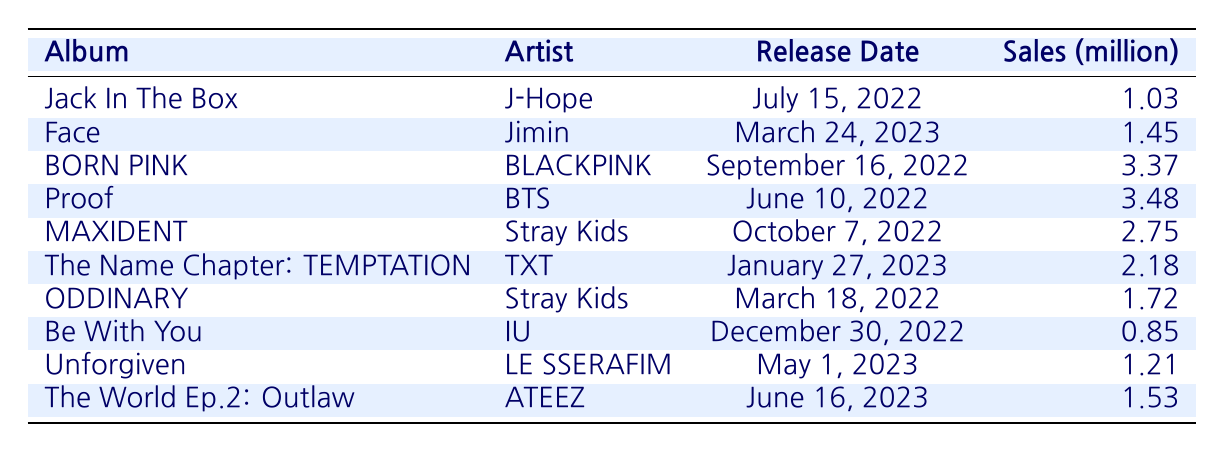What is the title of the album with the highest sales? The album with the highest sales is "Proof" with 3.48 million units sold. This information can be found by looking at the sales column and identifying the maximum value.
Answer: Proof Who is the artist of the album “Face”? The album “Face” is by the artist Jimin. This can be directly found by correlating the album title in the table with its respective artist in the same row.
Answer: Jimin What is the total sales (in million) of the albums released in 2023? The albums released in 2023 are "Face" (1.45 million), "The Name Chapter: TEMPTATION" (2.18 million), "Unforgiven" (1.21 million), and "The World Ep.2: Outlaw" (1.53 million). Summing these values gives: 1.45 + 2.18 + 1.21 + 1.53 = 6.37 million.
Answer: 6.37 Did any album released in 2022 have sales greater than 3 million? Yes, the album "Proof" by BTS and "BORN PINK" by BLACKPINK both had sales greater than 3 million, with sales of 3.48 million and 3.37 million, respectively. I verified this by comparing their sales values in the table with 3 million.
Answer: Yes What is the average sales of all listed albums? To calculate the average sales, first sum all the sales values: 1.03 + 1.45 + 3.37 + 3.48 + 2.75 + 2.18 + 1.72 + 0.85 + 1.21 + 1.53 = 19.38 million. Since there are 10 albums, the average is 19.38 / 10 = 1.938 million.
Answer: 1.938 Which artist has the least sold album on this list? The artist with the least sold album is IU, with the album "Be With You" having sales of 0.85 million. This is determined by looking at the sales column and finding the minimum value, which corresponds to IU's album.
Answer: IU How many albums were released before 2023? There are six albums released before 2023: "Jack In The Box", "BORN PINK", "Proof", "MAXIDENT", "ODDINARY", and "Be With You", found by identifying release dates earlier than January 1, 2023 in the table.
Answer: 6 Is there an album by Stray Kids that was released in 2023? No, Stray Kids released "MAXIDENT" in October 2022 and "ODDINARY" in March 2022, but there is no album listed for Stray Kids for 2023. This is confirmed by checking their entries in the table.
Answer: No 